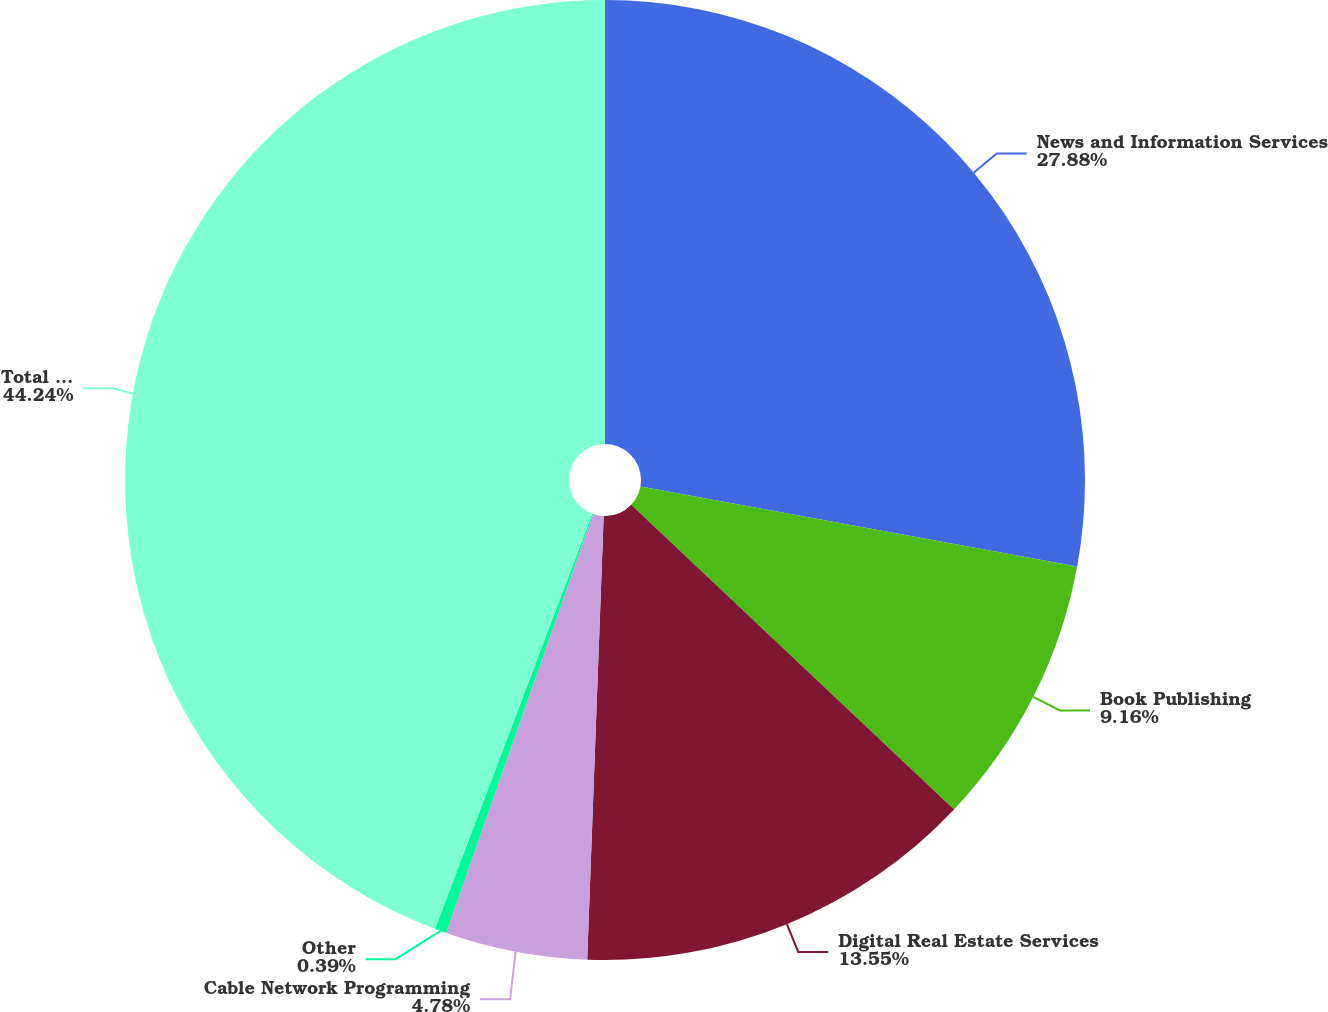<chart> <loc_0><loc_0><loc_500><loc_500><pie_chart><fcel>News and Information Services<fcel>Book Publishing<fcel>Digital Real Estate Services<fcel>Cable Network Programming<fcel>Other<fcel>Total Depreciation and<nl><fcel>27.88%<fcel>9.16%<fcel>13.55%<fcel>4.78%<fcel>0.39%<fcel>44.24%<nl></chart> 